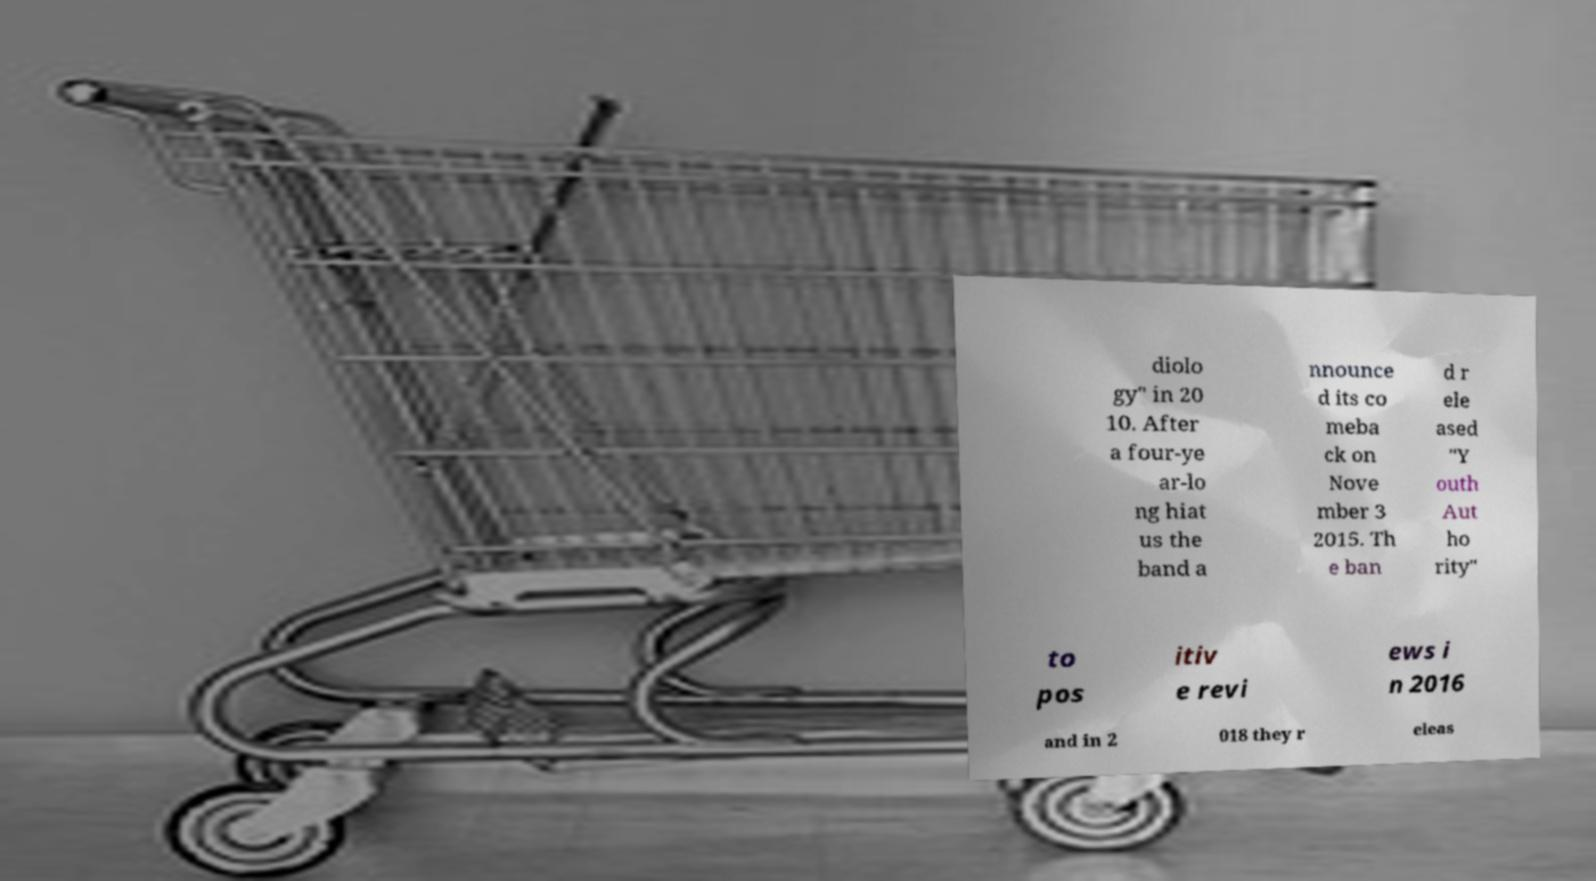What messages or text are displayed in this image? I need them in a readable, typed format. diolo gy" in 20 10. After a four-ye ar-lo ng hiat us the band a nnounce d its co meba ck on Nove mber 3 2015. Th e ban d r ele ased "Y outh Aut ho rity" to pos itiv e revi ews i n 2016 and in 2 018 they r eleas 